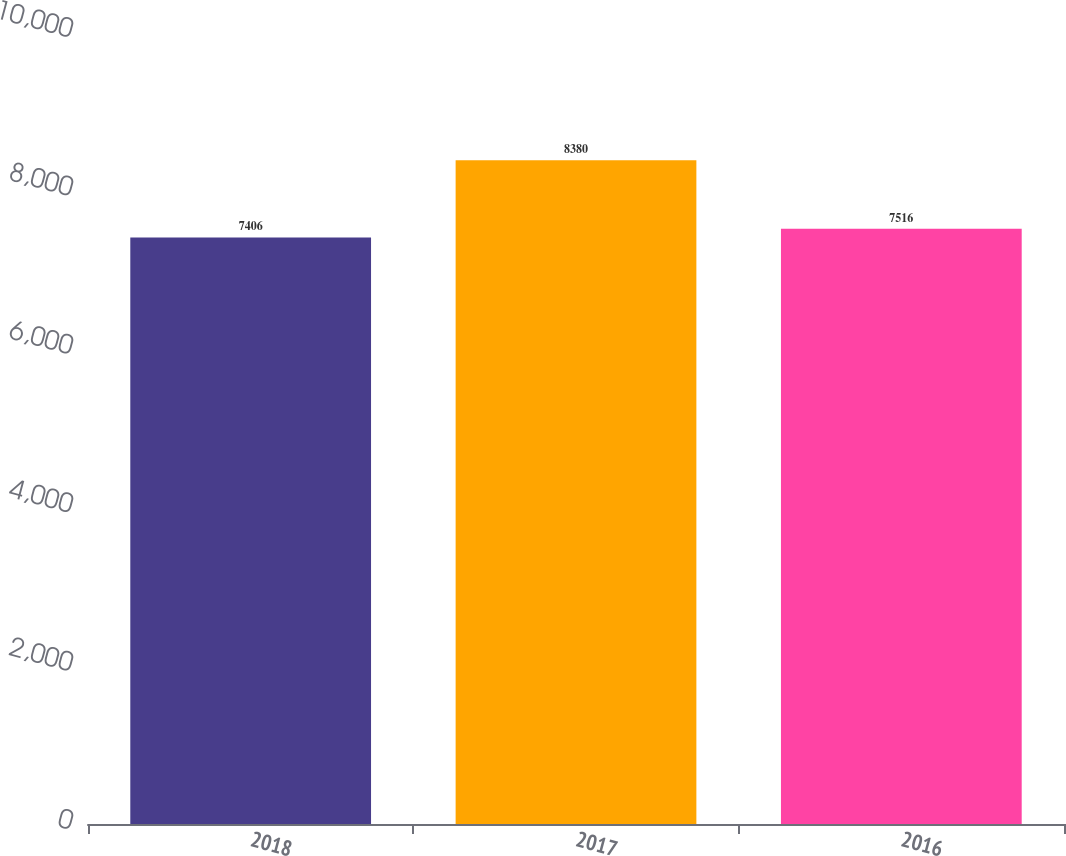Convert chart to OTSL. <chart><loc_0><loc_0><loc_500><loc_500><bar_chart><fcel>2018<fcel>2017<fcel>2016<nl><fcel>7406<fcel>8380<fcel>7516<nl></chart> 